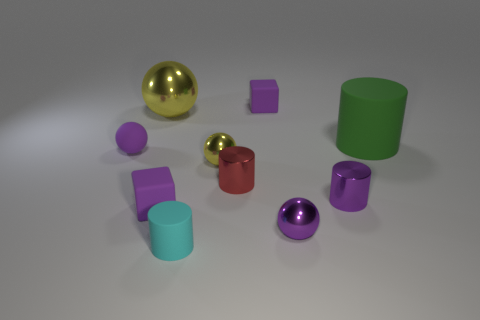Subtract all small rubber cylinders. How many cylinders are left? 3 Subtract all yellow cubes. How many purple spheres are left? 2 Subtract all purple cylinders. How many cylinders are left? 3 Subtract all brown cylinders. Subtract all purple balls. How many cylinders are left? 4 Subtract all cubes. How many objects are left? 8 Subtract all big green rubber cylinders. Subtract all yellow objects. How many objects are left? 7 Add 2 big green cylinders. How many big green cylinders are left? 3 Add 4 large yellow shiny balls. How many large yellow shiny balls exist? 5 Subtract 1 red cylinders. How many objects are left? 9 